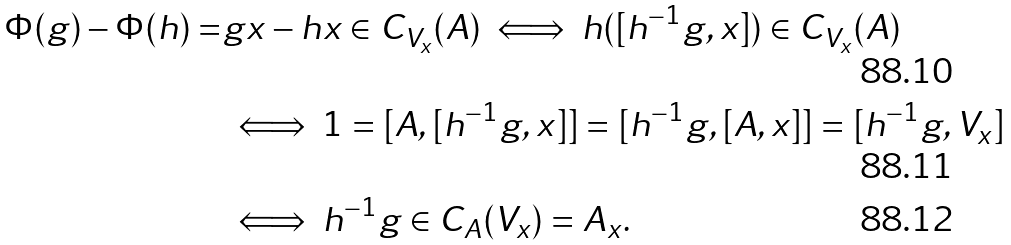<formula> <loc_0><loc_0><loc_500><loc_500>\Phi ( g ) - \Phi ( h ) = & g x - h x \in C _ { V _ { x } } ( A ) \iff h ( [ h ^ { - 1 } g , x ] ) \in C _ { V _ { x } } ( A ) \\ & \iff 1 = [ A , [ h ^ { - 1 } g , x ] ] = [ h ^ { - 1 } g , [ A , x ] ] = [ h ^ { - 1 } g , V _ { x } ] \\ & \iff h ^ { - 1 } g \in C _ { A } ( V _ { x } ) = A _ { x } .</formula> 